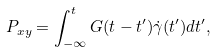<formula> <loc_0><loc_0><loc_500><loc_500>P _ { x y } = \int _ { - \infty } ^ { t } G ( t - t ^ { \prime } ) \dot { \gamma } ( t ^ { \prime } ) d t ^ { \prime } ,</formula> 